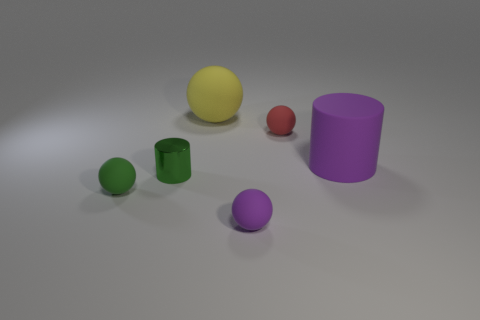What is the mood or atmosphere conveyed by the scene depicted? The scene in the image conveys a calm and neutral atmosphere. The soft lighting and the plain background do not evoke a strong emotional response, but rather provide a neutral setting that places focus on the shapes and colors of the objects. The arrangement of the objects is orderly and balanced, which adds to the overall serene feeling. 